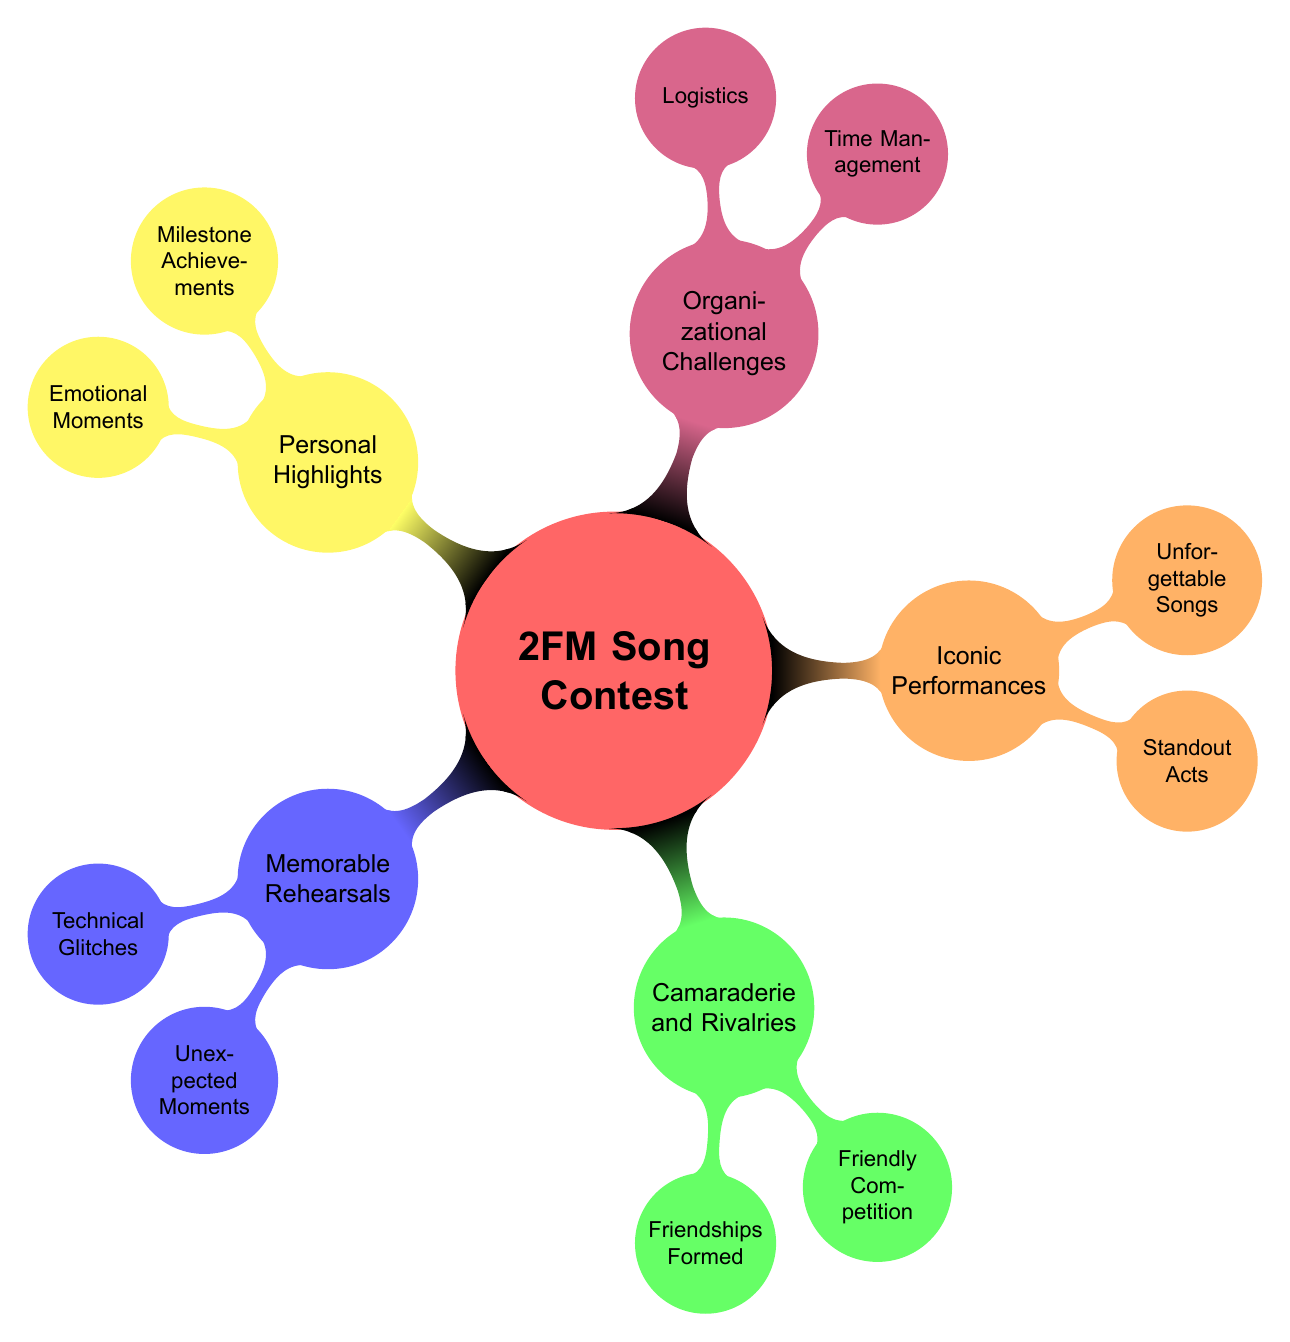What is the main topic of the mind map? The main topic of the mind map is indicated at the center, which is labeled as "2FM Song Contest."
Answer: 2FM Song Contest How many main branches are there in the mind map? The mind map consists of five main branches, each representing different categories related to the contest.
Answer: 5 What is an example of a technical glitch mentioned in the diagram? The details of "Memorable Rehearsals" include "Technical Glitches," with "Microphone Issues" provided as an example.
Answer: Microphone Issues What is one example of unexpected moments in the rehearsals? The "Unexpected Moments" under "Memorable Rehearsals" includes "Acoustic Jam Sessions" as an example.
Answer: Acoustic Jam Sessions Which category includes milestones and emotional moments? The "Personal Highlights" category addresses both "Milestone Achievements" and "Emotional Moments."
Answer: Personal Highlights How are friendships formed during the contest? Under "Camaraderie and Rivalries," the node "Friendships Formed" specifically addresses how friendships emerge, with "Backstage Bonding" as an example.
Answer: Backstage Bonding Which category would you find "Scheduling Conflicts"? "Scheduling Conflicts" is an example listed under "Organizational Challenges," highlighting time management issues.
Answer: Organizational Challenges What type of moments are described under the "Iconic Performances" branch? The branch "Iconic Performances" entails standout acts and unforgettable songs, which are categorized as memorable performances during the contest.
Answer: Iconic Performances Which category highlights friendly competitions among participants? "Camaraderie and Rivalries" focuses on friendly competition, showcasing interactions such as wardrobe comparisons among contestants.
Answer: Camaraderie and Rivalries 